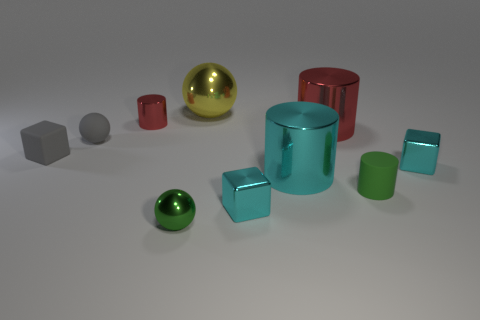What can you deduce about the scale of these objects? Given the lack of familiar reference points, it's challenging to deduce the scale precisely. However, the size relationships between the objects suggest they might be miniature, possibly models used for a display or a study. 